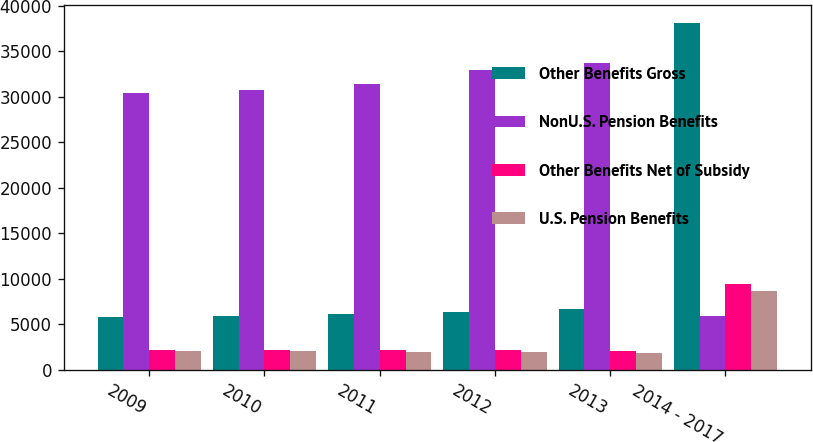<chart> <loc_0><loc_0><loc_500><loc_500><stacked_bar_chart><ecel><fcel>2009<fcel>2010<fcel>2011<fcel>2012<fcel>2013<fcel>2014 - 2017<nl><fcel>Other Benefits Gross<fcel>5788<fcel>5891<fcel>6119<fcel>6365<fcel>6725<fcel>38118<nl><fcel>NonU.S. Pension Benefits<fcel>30432<fcel>30782<fcel>31390<fcel>32920<fcel>33650<fcel>5891<nl><fcel>Other Benefits Net of Subsidy<fcel>2197<fcel>2205<fcel>2183<fcel>2142<fcel>2069<fcel>9435<nl><fcel>U.S. Pension Benefits<fcel>2039<fcel>2039<fcel>2013<fcel>1969<fcel>1896<fcel>8648<nl></chart> 